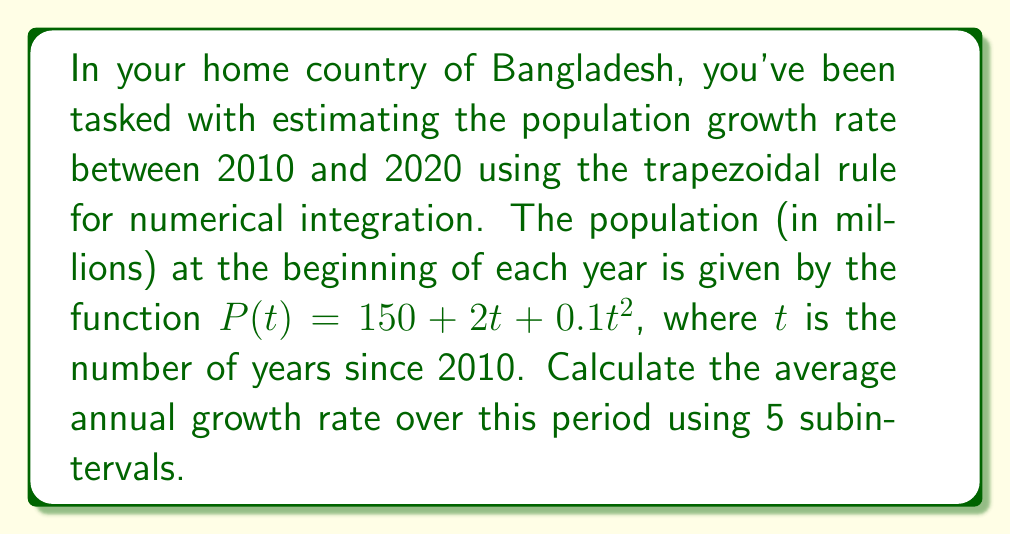Can you solve this math problem? 1) The average growth rate is given by:
   $$\text{Average Growth Rate} = \frac{\text{Total Growth}}{\text{Initial Population} \times \text{Number of Years}}$$

2) To find the total growth, we need to integrate the rate of change of population:
   $$\text{Total Growth} = \int_0^{10} \frac{dP}{dt} dt$$

3) The derivative of $P(t)$ is:
   $$\frac{dP}{dt} = 2 + 0.2t$$

4) We'll use the trapezoidal rule with 5 subintervals (n = 5) to approximate the integral:
   $$\int_0^{10} f(t) dt \approx \frac{b-a}{2n} [f(t_0) + 2f(t_1) + 2f(t_2) + 2f(t_3) + 2f(t_4) + f(t_5)]$$

5) Calculate function values at each point:
   $t_0 = 0$: $f(0) = 2$
   $t_1 = 2$: $f(2) = 2.4$
   $t_2 = 4$: $f(4) = 2.8$
   $t_3 = 6$: $f(6) = 3.2$
   $t_4 = 8$: $f(8) = 3.6$
   $t_5 = 10$: $f(10) = 4$

6) Apply the trapezoidal rule:
   $$\text{Total Growth} \approx \frac{10}{10} [2 + 2(2.4) + 2(2.8) + 2(3.2) + 2(3.6) + 4] = 28$$

7) Calculate the initial population (at t = 0):
   $$P(0) = 150 + 2(0) + 0.1(0)^2 = 150 \text{ million}$$

8) Calculate the average annual growth rate:
   $$\text{Average Growth Rate} = \frac{28}{150 \times 10} = 0.01867$$

9) Convert to percentage:
   $$\text{Average Growth Rate} = 1.867\%$$
Answer: 1.867% 